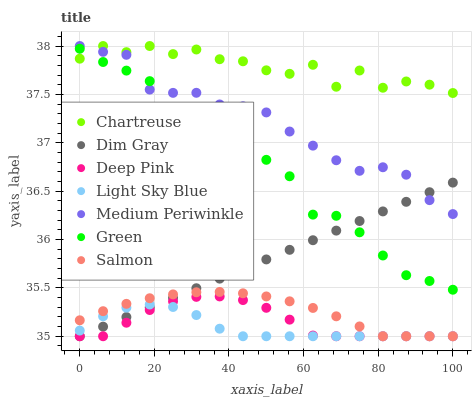Does Light Sky Blue have the minimum area under the curve?
Answer yes or no. Yes. Does Chartreuse have the maximum area under the curve?
Answer yes or no. Yes. Does Salmon have the minimum area under the curve?
Answer yes or no. No. Does Salmon have the maximum area under the curve?
Answer yes or no. No. Is Dim Gray the smoothest?
Answer yes or no. Yes. Is Green the roughest?
Answer yes or no. Yes. Is Salmon the smoothest?
Answer yes or no. No. Is Salmon the roughest?
Answer yes or no. No. Does Dim Gray have the lowest value?
Answer yes or no. Yes. Does Medium Periwinkle have the lowest value?
Answer yes or no. No. Does Chartreuse have the highest value?
Answer yes or no. Yes. Does Salmon have the highest value?
Answer yes or no. No. Is Dim Gray less than Chartreuse?
Answer yes or no. Yes. Is Chartreuse greater than Salmon?
Answer yes or no. Yes. Does Salmon intersect Deep Pink?
Answer yes or no. Yes. Is Salmon less than Deep Pink?
Answer yes or no. No. Is Salmon greater than Deep Pink?
Answer yes or no. No. Does Dim Gray intersect Chartreuse?
Answer yes or no. No. 